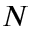Convert formula to latex. <formula><loc_0><loc_0><loc_500><loc_500>N</formula> 